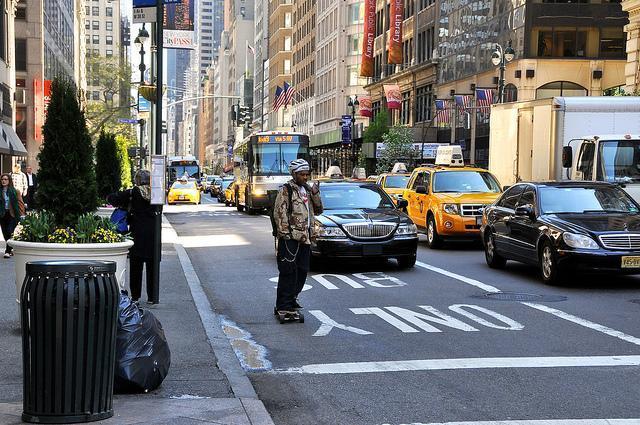How many people are there?
Give a very brief answer. 2. How many cars can you see?
Give a very brief answer. 3. 